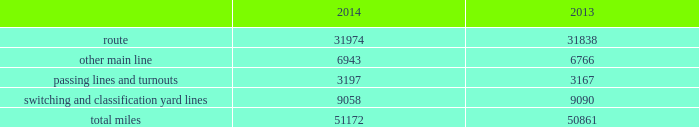Item 1b .
Unresolved staff comments item 2 .
Properties we employ a variety of assets in the management and operation of our rail business .
Our rail network covers 23 states in the western two-thirds of the u.s .
Our rail network includes 31974 route miles .
We own 26012 miles and operate on the remainder pursuant to trackage rights or leases .
The table describes track miles at december 31 , 2014 and 2013 .
2014 2013 .
Headquarters building we own our headquarters building in omaha , nebraska .
The facility has 1.2 million square feet of space for approximately 4000 employees. .
What percentage of total miles were other main line in 2014? 
Computations: (6943 / 51172)
Answer: 0.13568. 